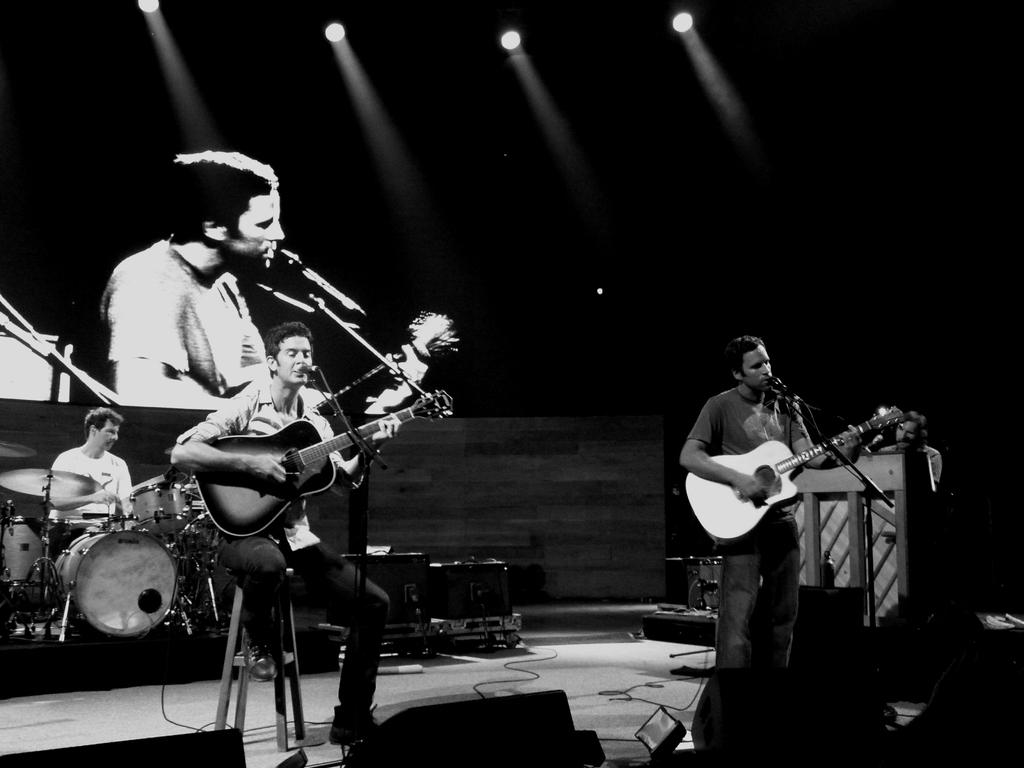What is happening on the stage in the image? There is a band performing on a stage. What instruments are being played by the band members? Two men are playing guitars and singing, while one man is playing drums. What type of snow can be seen falling on the stage during the band's performance? There is no snow present in the image; it is a band performing on a stage. 